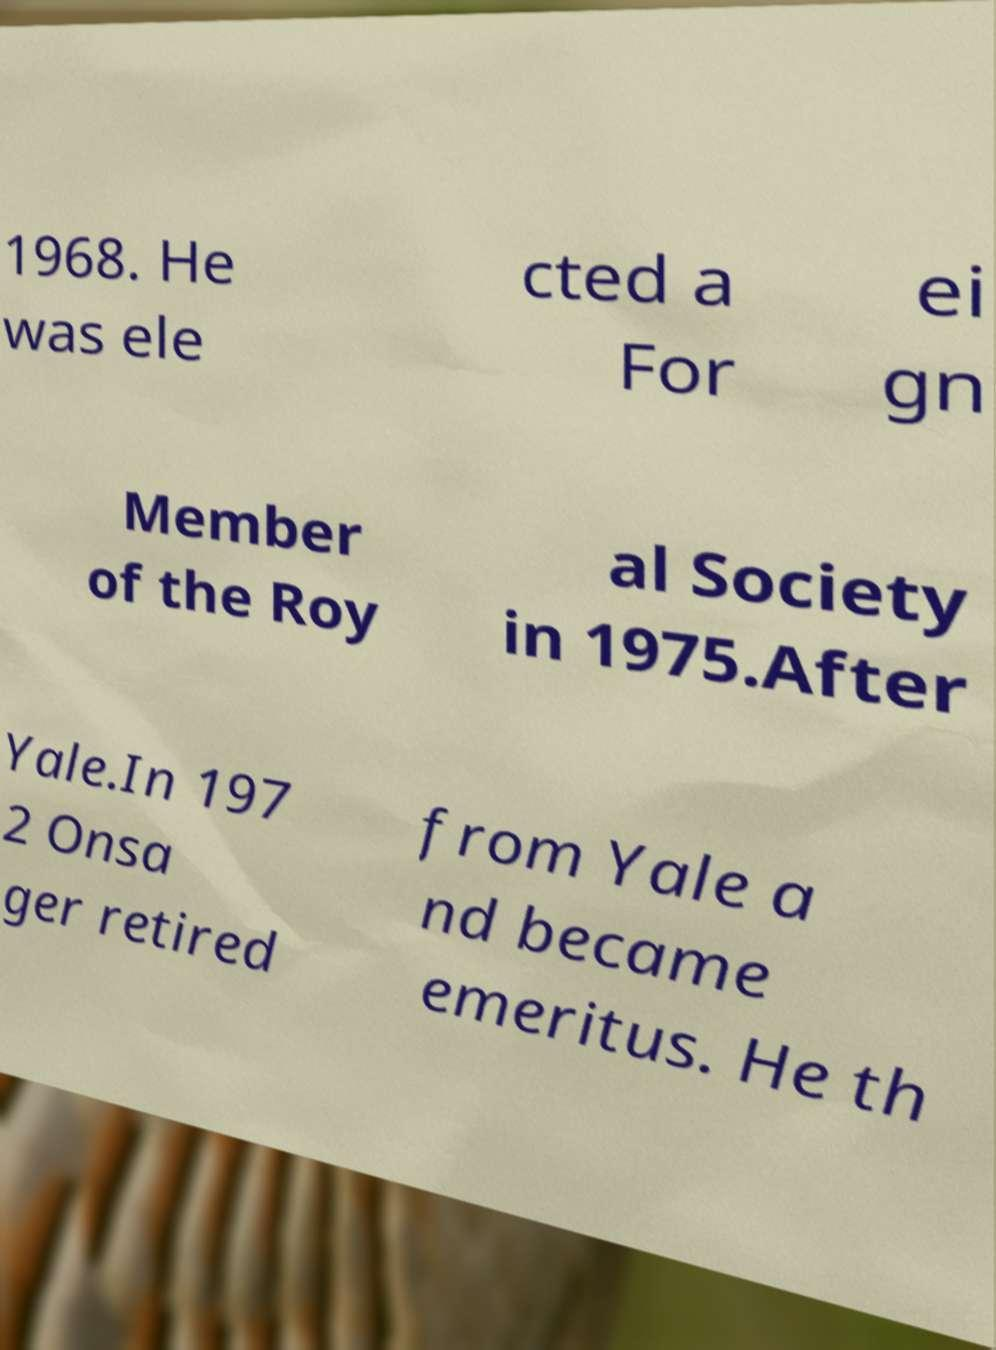I need the written content from this picture converted into text. Can you do that? 1968. He was ele cted a For ei gn Member of the Roy al Society in 1975.After Yale.In 197 2 Onsa ger retired from Yale a nd became emeritus. He th 